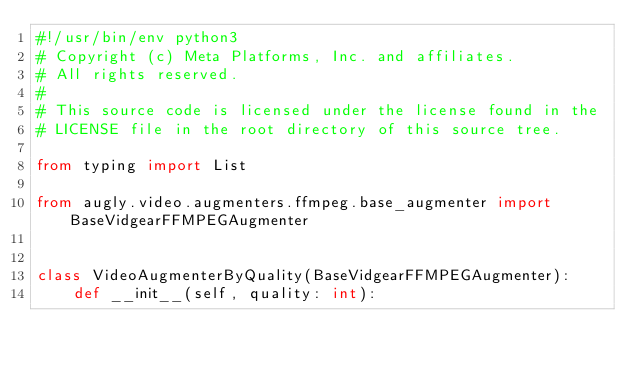<code> <loc_0><loc_0><loc_500><loc_500><_Python_>#!/usr/bin/env python3
# Copyright (c) Meta Platforms, Inc. and affiliates.
# All rights reserved.
#
# This source code is licensed under the license found in the
# LICENSE file in the root directory of this source tree.

from typing import List

from augly.video.augmenters.ffmpeg.base_augmenter import BaseVidgearFFMPEGAugmenter


class VideoAugmenterByQuality(BaseVidgearFFMPEGAugmenter):
    def __init__(self, quality: int):</code> 